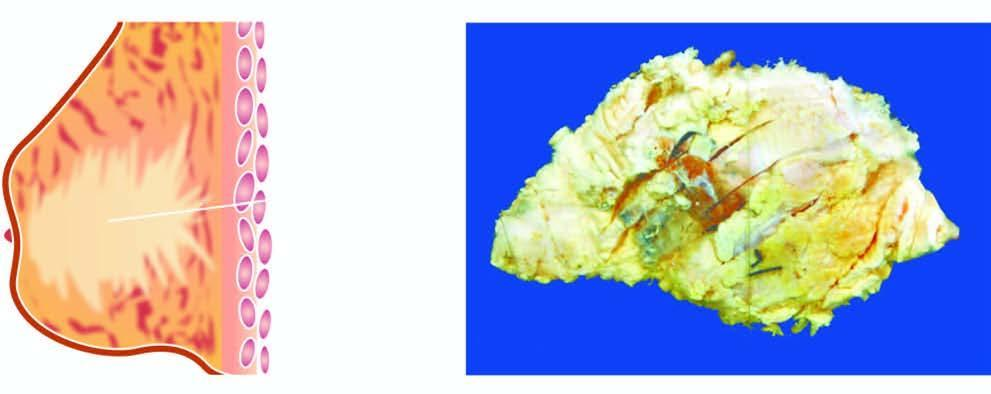what shows a grey white firm tumour extending irregularly into adjacent breast parenchyma?
Answer the question using a single word or phrase. Cut surface 